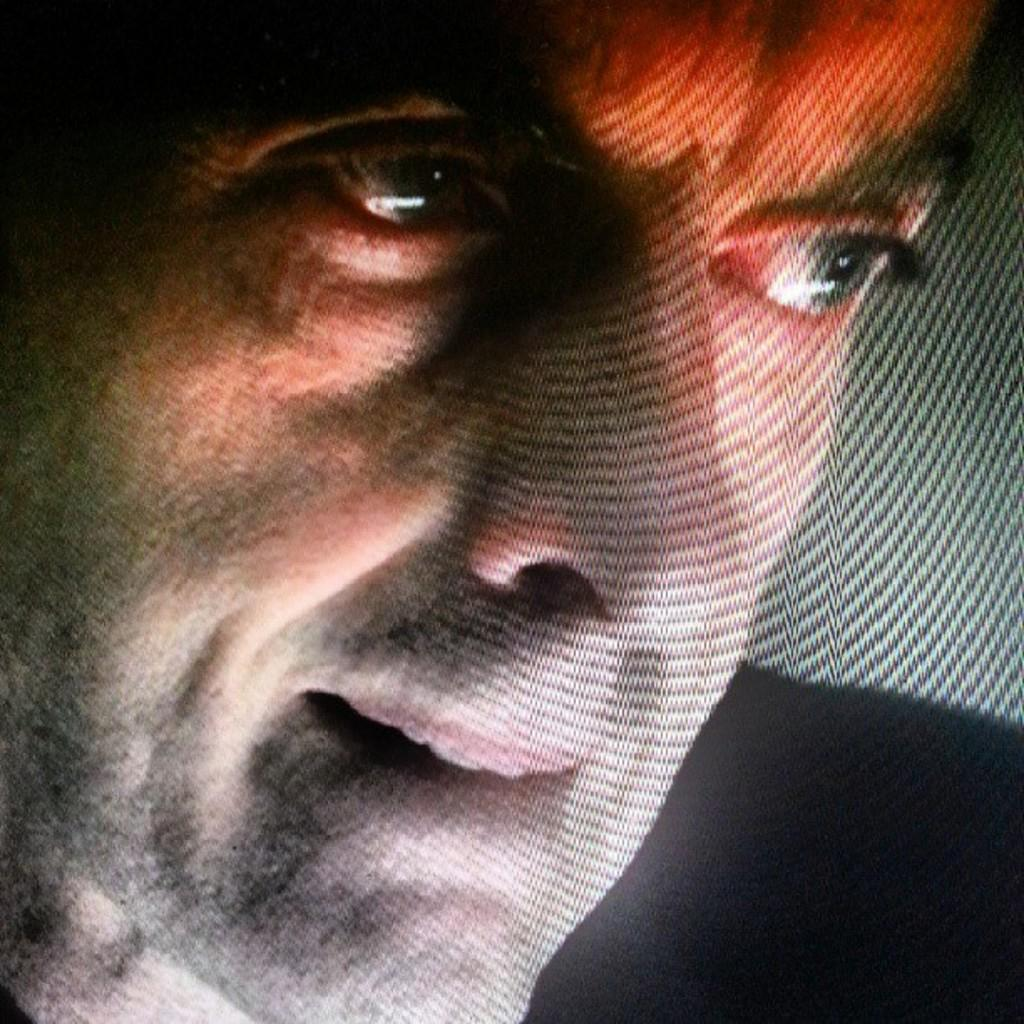What is the main subject of the image? There is a man in the image. How is the image being displayed? The image appears to be displayed on a screen. What type of knowledge is the man sharing with others in the image? There is no indication in the image that the man is sharing any knowledge with others. Is the man making any payments in the image? There is no indication in the image that the man is making any payments. Can you see any sails in the image? There is no mention of sails or any related objects in the provided facts, so we cannot determine if they are present in the image. 